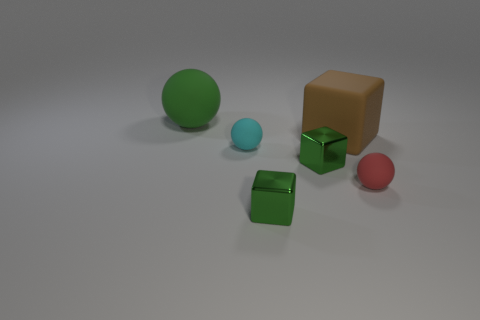What number of other objects are the same color as the rubber block?
Offer a very short reply. 0. The tiny cyan matte object that is in front of the brown rubber object has what shape?
Offer a terse response. Sphere. Do the cyan object and the small red object have the same material?
Your answer should be very brief. Yes. Are there any other things that have the same size as the cyan sphere?
Your response must be concise. Yes. There is a small cyan object; what number of small red rubber things are behind it?
Your answer should be very brief. 0. What is the shape of the metal thing that is in front of the rubber sphere that is right of the cyan rubber object?
Give a very brief answer. Cube. Are there any other things that have the same shape as the red matte thing?
Offer a terse response. Yes. Are there more red objects that are to the left of the small red thing than big brown rubber things?
Give a very brief answer. No. There is a tiny matte ball that is to the right of the large brown matte thing; how many large balls are in front of it?
Make the answer very short. 0. What shape is the small matte thing that is on the right side of the big object on the right side of the big thing that is on the left side of the large matte block?
Your response must be concise. Sphere. 